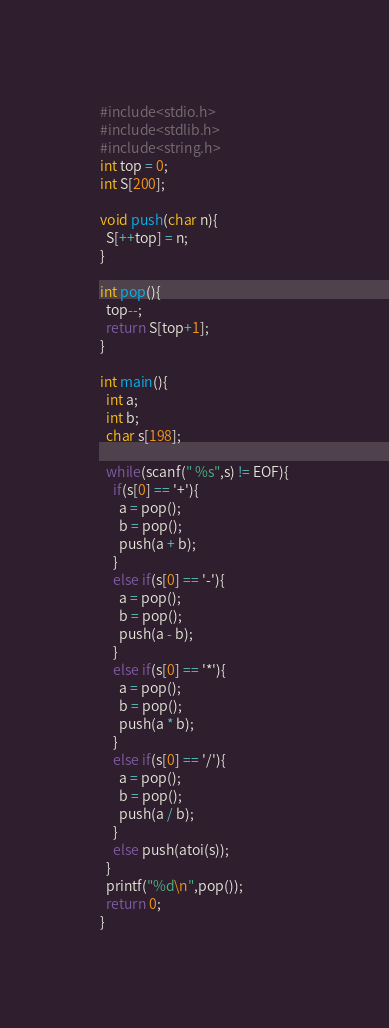Convert code to text. <code><loc_0><loc_0><loc_500><loc_500><_C_>#include<stdio.h>
#include<stdlib.h>
#include<string.h>
int top = 0;
int S[200];

void push(char n){
  S[++top] = n;
}

int pop(){
  top--;
  return S[top+1];
}

int main(){
  int a;
  int b;
  char s[198];

  while(scanf(" %s",s) != EOF){
    if(s[0] == '+'){
      a = pop();
      b = pop();
      push(a + b);
    }
    else if(s[0] == '-'){
      a = pop();
      b = pop();
      push(a - b);
    }
    else if(s[0] == '*'){
      a = pop();
      b = pop();
      push(a * b);
    }
    else if(s[0] == '/'){
      a = pop();
      b = pop();
      push(a / b);
    }
    else push(atoi(s));
  }
  printf("%d\n",pop());
  return 0;
}




</code> 